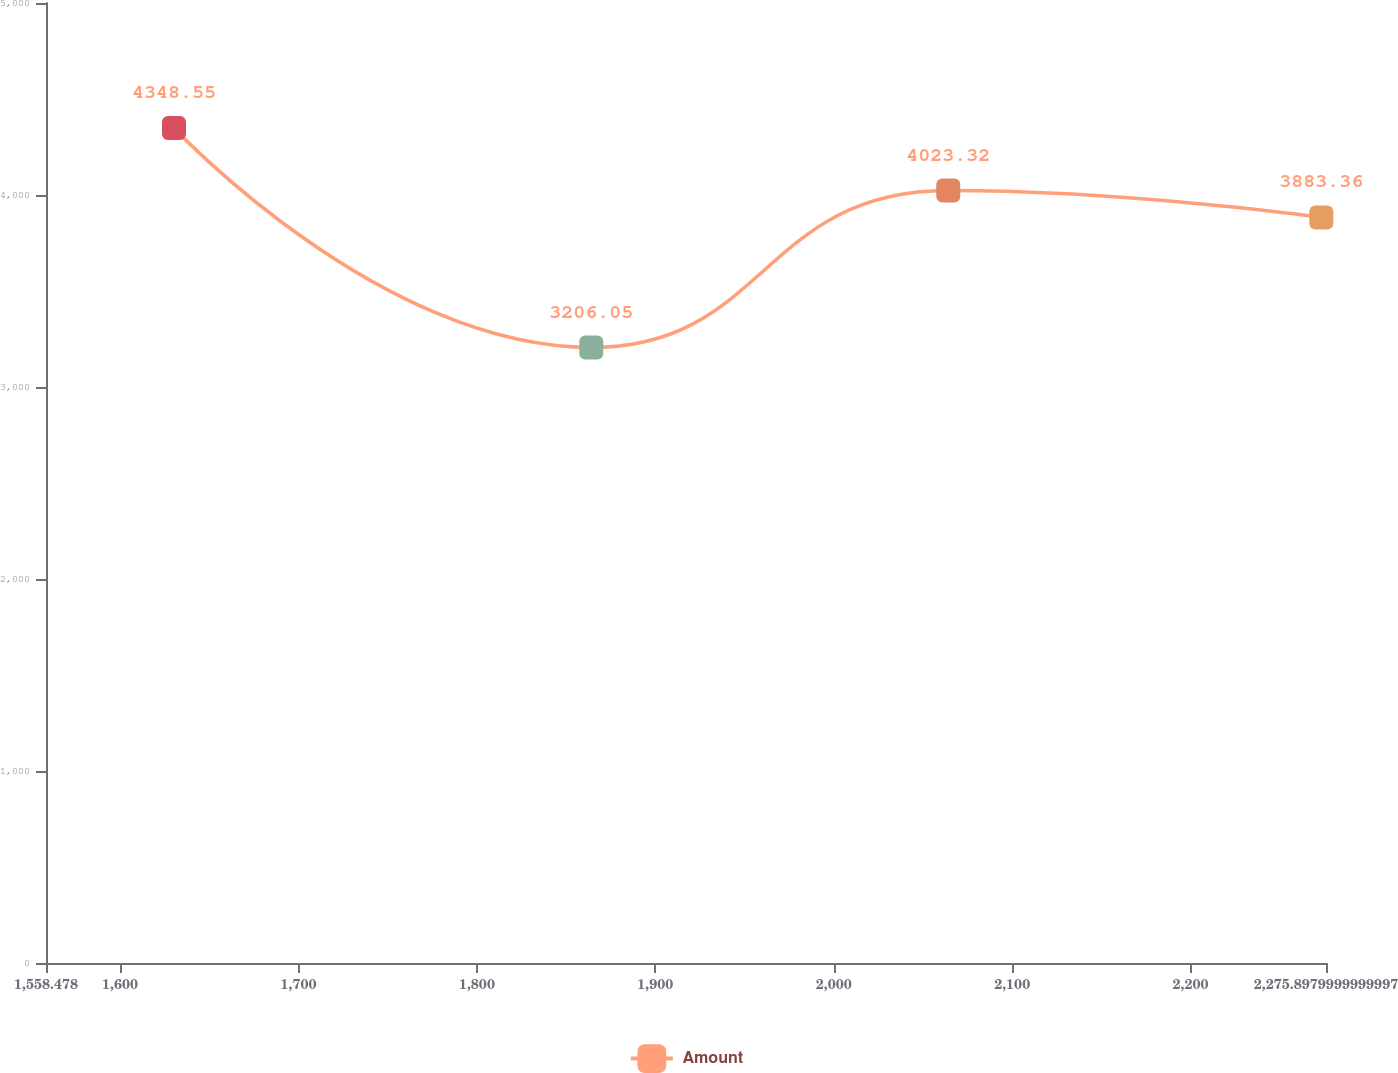Convert chart. <chart><loc_0><loc_0><loc_500><loc_500><line_chart><ecel><fcel>Amount<nl><fcel>1630.22<fcel>4348.55<nl><fcel>1864.11<fcel>3206.05<nl><fcel>2064.19<fcel>4023.32<nl><fcel>2273.3<fcel>3883.36<nl><fcel>2347.64<fcel>2948.94<nl></chart> 